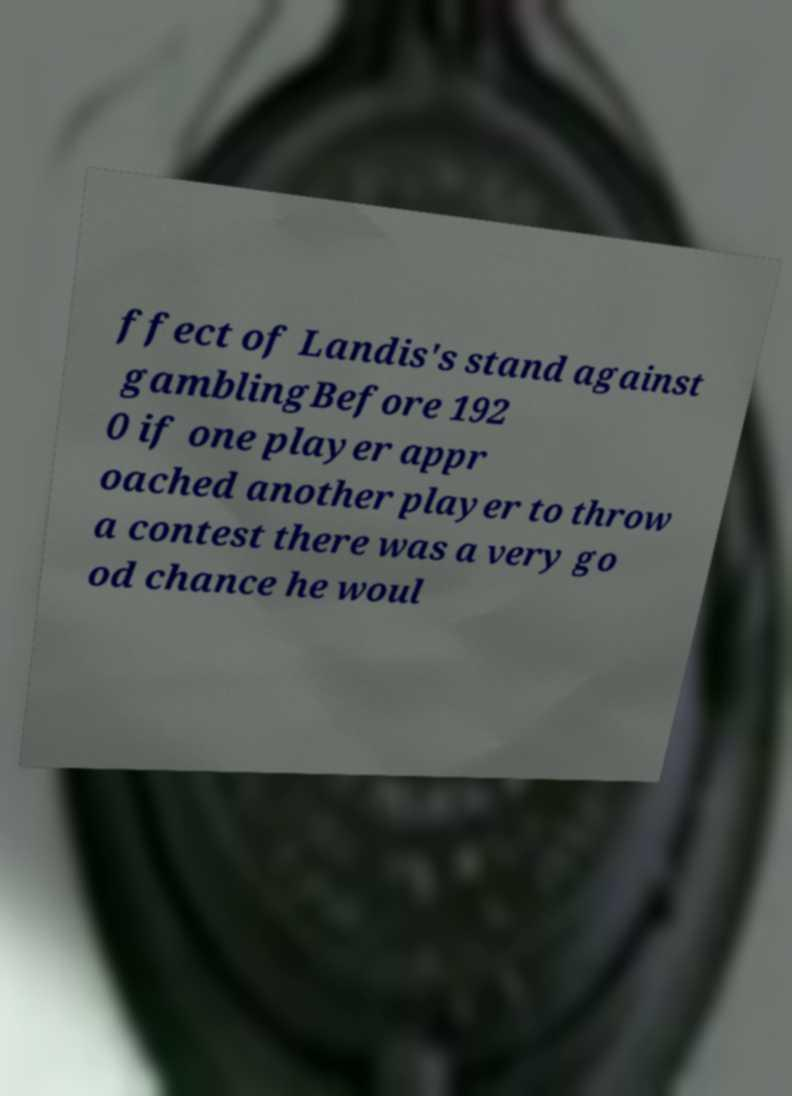For documentation purposes, I need the text within this image transcribed. Could you provide that? ffect of Landis's stand against gamblingBefore 192 0 if one player appr oached another player to throw a contest there was a very go od chance he woul 